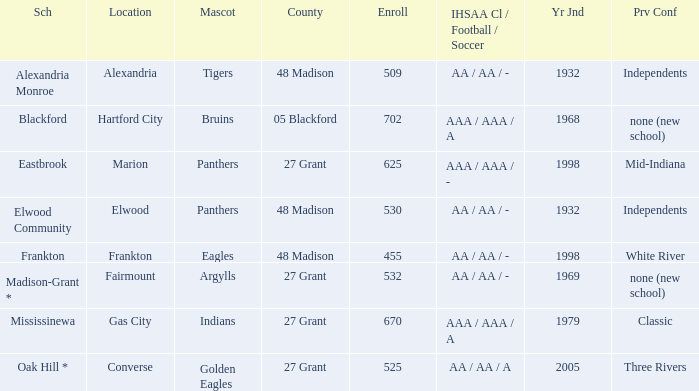What is the previous conference when the location is converse? Three Rivers. 